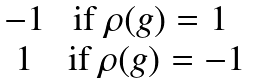<formula> <loc_0><loc_0><loc_500><loc_500>\begin{matrix} - 1 & \text {if $\rho(g)=1$} \, \\ 1 & \, \text {if $\rho(g)=-1$} \end{matrix}</formula> 